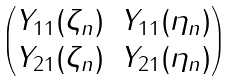Convert formula to latex. <formula><loc_0><loc_0><loc_500><loc_500>\begin{pmatrix} Y _ { 1 1 } ( \zeta _ { n } ) & Y _ { 1 1 } ( \eta _ { n } ) \\ Y _ { 2 1 } ( \zeta _ { n } ) & Y _ { 2 1 } ( \eta _ { n } ) \end{pmatrix}</formula> 